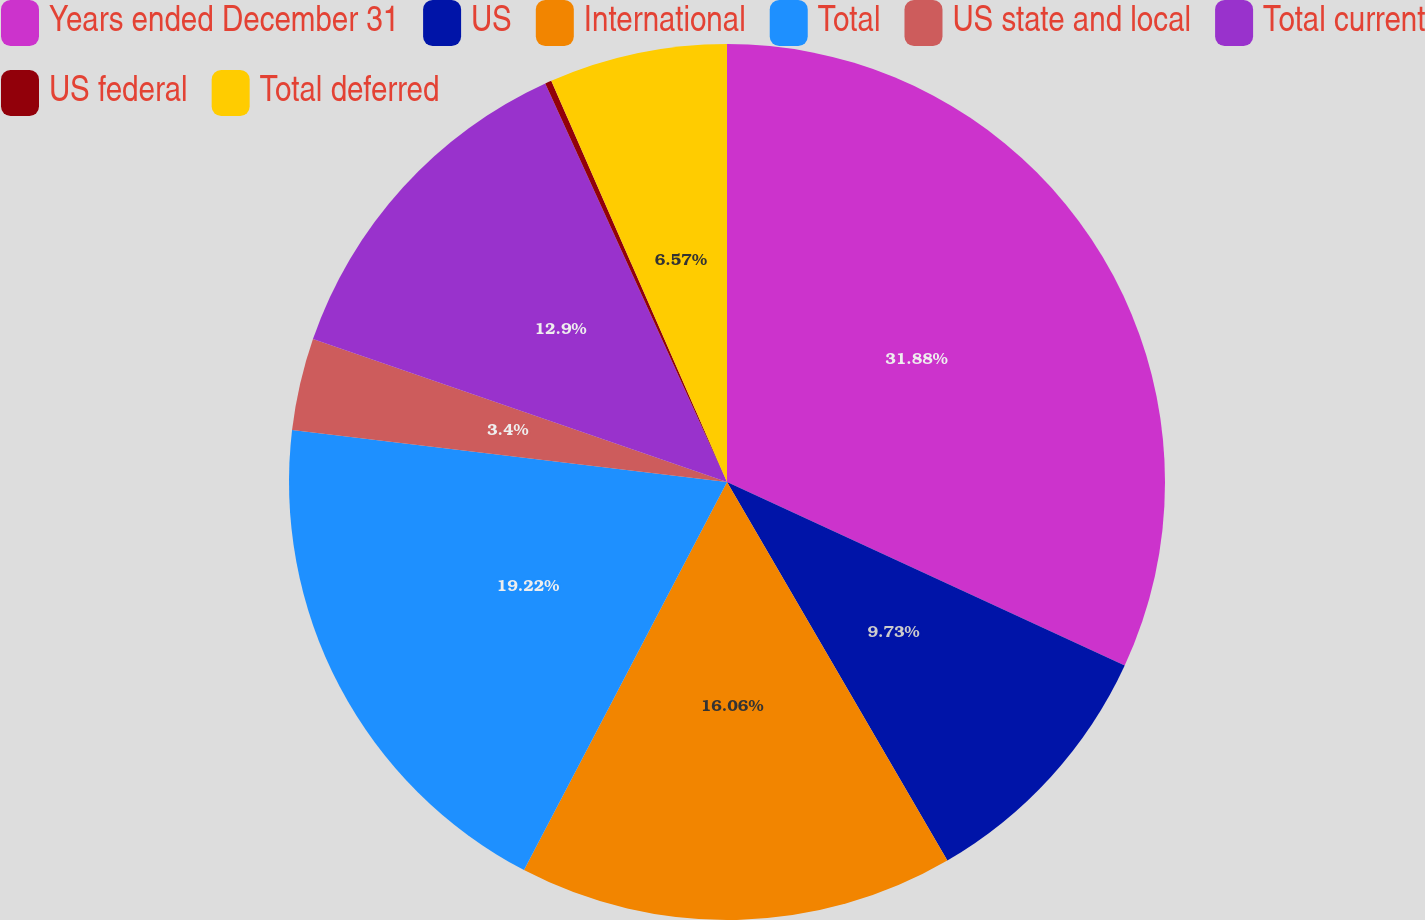Convert chart to OTSL. <chart><loc_0><loc_0><loc_500><loc_500><pie_chart><fcel>Years ended December 31<fcel>US<fcel>International<fcel>Total<fcel>US state and local<fcel>Total current<fcel>US federal<fcel>Total deferred<nl><fcel>31.88%<fcel>9.73%<fcel>16.06%<fcel>19.22%<fcel>3.4%<fcel>12.9%<fcel>0.24%<fcel>6.57%<nl></chart> 